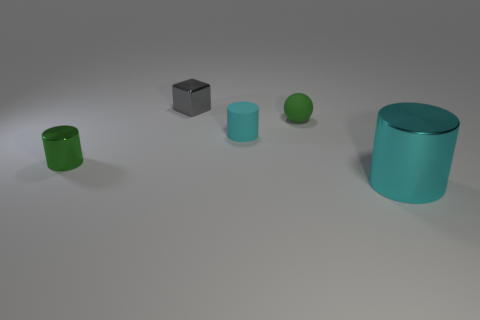Add 4 large cubes. How many objects exist? 9 Subtract all spheres. How many objects are left? 4 Add 5 green shiny things. How many green shiny things are left? 6 Add 1 large green spheres. How many large green spheres exist? 1 Subtract 0 cyan blocks. How many objects are left? 5 Subtract all purple spheres. Subtract all small metallic cubes. How many objects are left? 4 